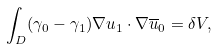Convert formula to latex. <formula><loc_0><loc_0><loc_500><loc_500>\int _ { D } ( \gamma _ { 0 } - \gamma _ { 1 } ) \nabla u _ { 1 } \cdot \nabla \overline { u } _ { 0 } = \delta V ,</formula> 